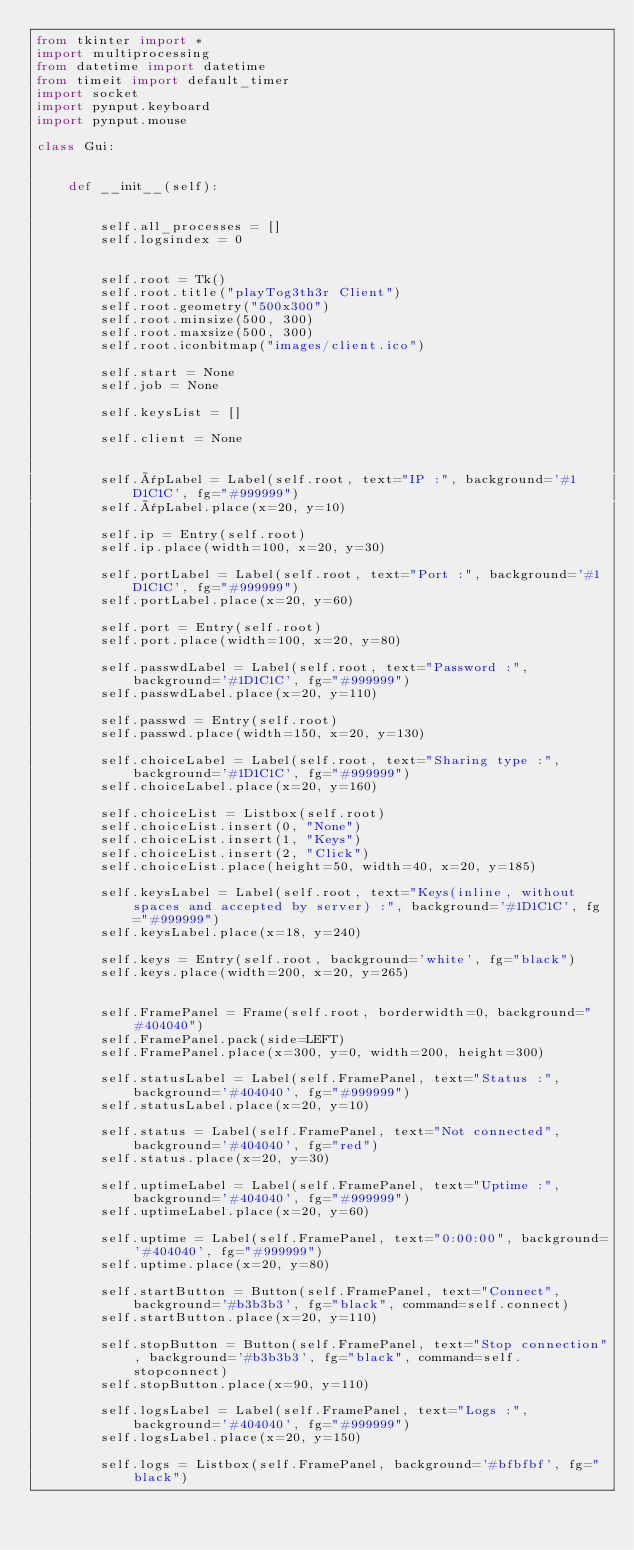Convert code to text. <code><loc_0><loc_0><loc_500><loc_500><_Python_>from tkinter import *
import multiprocessing
from datetime import datetime
from timeit import default_timer
import socket
import pynput.keyboard
import pynput.mouse

class Gui:


    def __init__(self):


        self.all_processes = []  
        self.logsindex = 0 

        
        self.root = Tk()
        self.root.title("playTog3th3r Client")
        self.root.geometry("500x300")
        self.root.minsize(500, 300)
        self.root.maxsize(500, 300)
        self.root.iconbitmap("images/client.ico")

        self.start = None  
        self.job = None 

        self.keysList = []  

        self.client = None 


        self.ïpLabel = Label(self.root, text="IP :", background='#1D1C1C', fg="#999999")
        self.ïpLabel.place(x=20, y=10)

        self.ip = Entry(self.root)
        self.ip.place(width=100, x=20, y=30)

        self.portLabel = Label(self.root, text="Port :", background='#1D1C1C', fg="#999999")
        self.portLabel.place(x=20, y=60)

        self.port = Entry(self.root)
        self.port.place(width=100, x=20, y=80)

        self.passwdLabel = Label(self.root, text="Password :", background='#1D1C1C', fg="#999999")
        self.passwdLabel.place(x=20, y=110)

        self.passwd = Entry(self.root)
        self.passwd.place(width=150, x=20, y=130)

        self.choiceLabel = Label(self.root, text="Sharing type :", background='#1D1C1C', fg="#999999")
        self.choiceLabel.place(x=20, y=160)

        self.choiceList = Listbox(self.root)
        self.choiceList.insert(0, "None")
        self.choiceList.insert(1, "Keys")
        self.choiceList.insert(2, "Click")
        self.choiceList.place(height=50, width=40, x=20, y=185)

        self.keysLabel = Label(self.root, text="Keys(inline, without spaces and accepted by server) :", background='#1D1C1C', fg="#999999")
        self.keysLabel.place(x=18, y=240)

        self.keys = Entry(self.root, background='white', fg="black")
        self.keys.place(width=200, x=20, y=265)


        self.FramePanel = Frame(self.root, borderwidth=0, background="#404040")
        self.FramePanel.pack(side=LEFT)
        self.FramePanel.place(x=300, y=0, width=200, height=300)

        self.statusLabel = Label(self.FramePanel, text="Status :", background='#404040', fg="#999999")
        self.statusLabel.place(x=20, y=10)

        self.status = Label(self.FramePanel, text="Not connected", background='#404040', fg="red")
        self.status.place(x=20, y=30)

        self.uptimeLabel = Label(self.FramePanel, text="Uptime :", background='#404040', fg="#999999")
        self.uptimeLabel.place(x=20, y=60)

        self.uptime = Label(self.FramePanel, text="0:00:00", background='#404040', fg="#999999")
        self.uptime.place(x=20, y=80)

        self.startButton = Button(self.FramePanel, text="Connect", background='#b3b3b3', fg="black", command=self.connect)
        self.startButton.place(x=20, y=110)

        self.stopButton = Button(self.FramePanel, text="Stop connection", background='#b3b3b3', fg="black", command=self.stopconnect)
        self.stopButton.place(x=90, y=110)

        self.logsLabel = Label(self.FramePanel, text="Logs :", background='#404040', fg="#999999")
        self.logsLabel.place(x=20, y=150)

        self.logs = Listbox(self.FramePanel, background='#bfbfbf', fg="black")</code> 